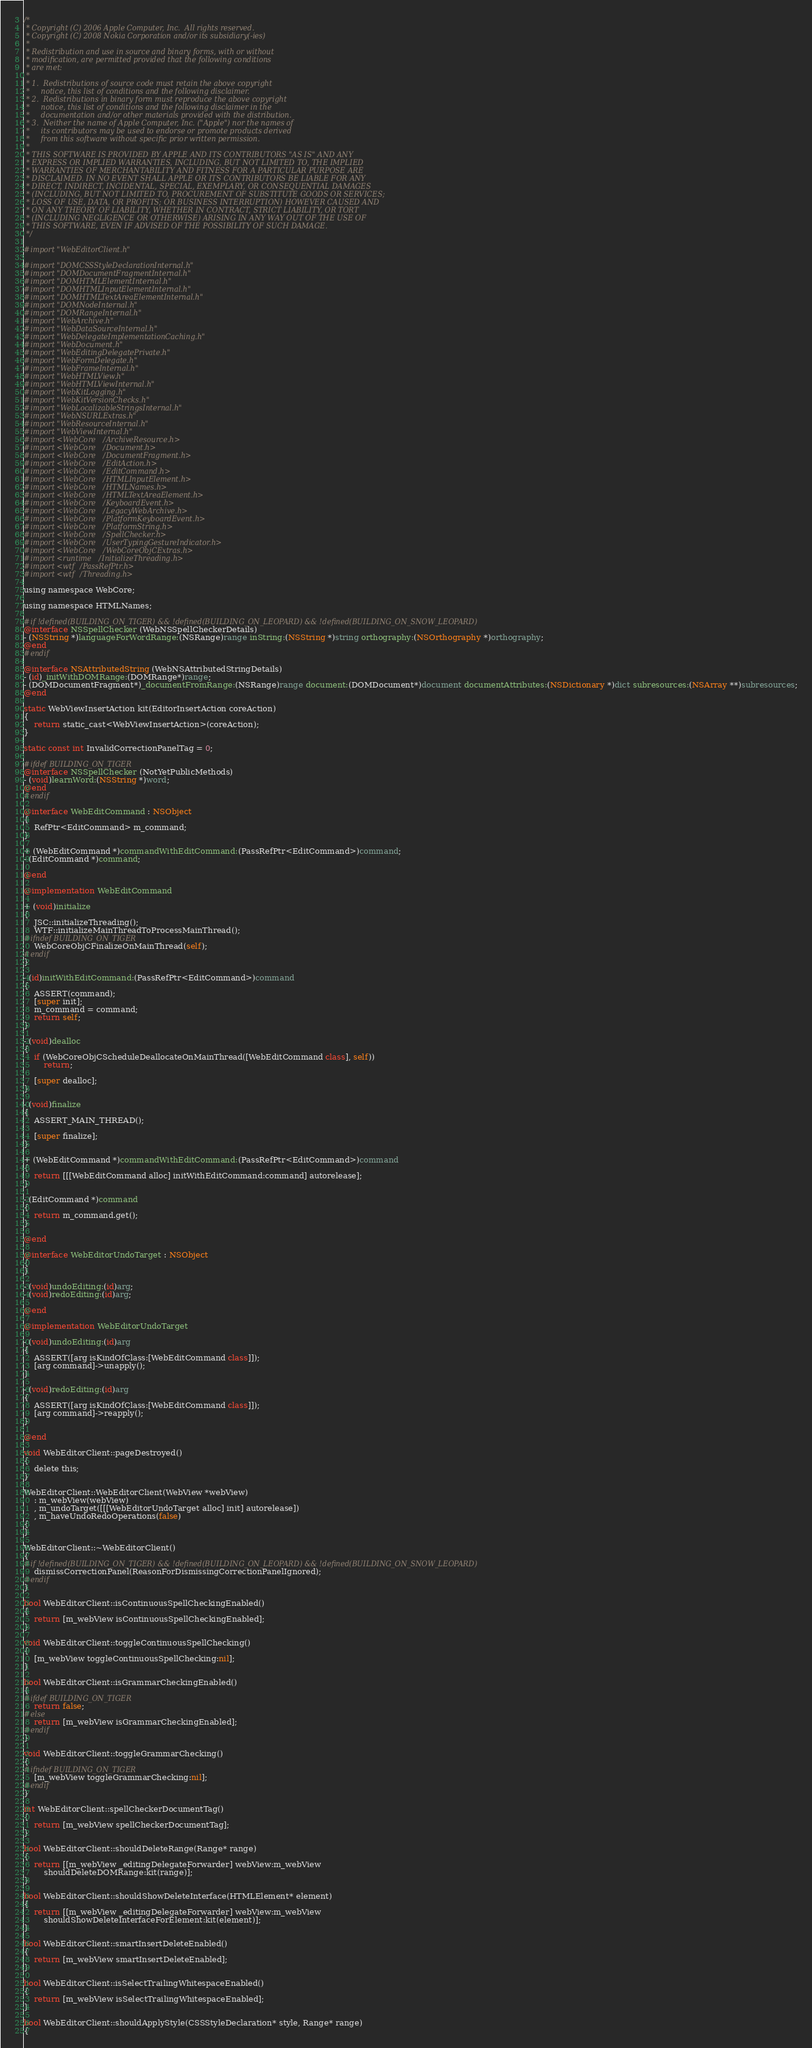Convert code to text. <code><loc_0><loc_0><loc_500><loc_500><_ObjectiveC_>/*
 * Copyright (C) 2006 Apple Computer, Inc.  All rights reserved.
 * Copyright (C) 2008 Nokia Corporation and/or its subsidiary(-ies)
 *
 * Redistribution and use in source and binary forms, with or without
 * modification, are permitted provided that the following conditions
 * are met:
 *
 * 1.  Redistributions of source code must retain the above copyright
 *     notice, this list of conditions and the following disclaimer. 
 * 2.  Redistributions in binary form must reproduce the above copyright
 *     notice, this list of conditions and the following disclaimer in the
 *     documentation and/or other materials provided with the distribution. 
 * 3.  Neither the name of Apple Computer, Inc. ("Apple") nor the names of
 *     its contributors may be used to endorse or promote products derived
 *     from this software without specific prior written permission. 
 *
 * THIS SOFTWARE IS PROVIDED BY APPLE AND ITS CONTRIBUTORS "AS IS" AND ANY
 * EXPRESS OR IMPLIED WARRANTIES, INCLUDING, BUT NOT LIMITED TO, THE IMPLIED
 * WARRANTIES OF MERCHANTABILITY AND FITNESS FOR A PARTICULAR PURPOSE ARE
 * DISCLAIMED. IN NO EVENT SHALL APPLE OR ITS CONTRIBUTORS BE LIABLE FOR ANY
 * DIRECT, INDIRECT, INCIDENTAL, SPECIAL, EXEMPLARY, OR CONSEQUENTIAL DAMAGES
 * (INCLUDING, BUT NOT LIMITED TO, PROCUREMENT OF SUBSTITUTE GOODS OR SERVICES;
 * LOSS OF USE, DATA, OR PROFITS; OR BUSINESS INTERRUPTION) HOWEVER CAUSED AND
 * ON ANY THEORY OF LIABILITY, WHETHER IN CONTRACT, STRICT LIABILITY, OR TORT
 * (INCLUDING NEGLIGENCE OR OTHERWISE) ARISING IN ANY WAY OUT OF THE USE OF
 * THIS SOFTWARE, EVEN IF ADVISED OF THE POSSIBILITY OF SUCH DAMAGE.
 */

#import "WebEditorClient.h"

#import "DOMCSSStyleDeclarationInternal.h"
#import "DOMDocumentFragmentInternal.h"
#import "DOMHTMLElementInternal.h"
#import "DOMHTMLInputElementInternal.h"
#import "DOMHTMLTextAreaElementInternal.h"
#import "DOMNodeInternal.h"
#import "DOMRangeInternal.h"
#import "WebArchive.h"
#import "WebDataSourceInternal.h"
#import "WebDelegateImplementationCaching.h"
#import "WebDocument.h"
#import "WebEditingDelegatePrivate.h"
#import "WebFormDelegate.h"
#import "WebFrameInternal.h"
#import "WebHTMLView.h"
#import "WebHTMLViewInternal.h"
#import "WebKitLogging.h"
#import "WebKitVersionChecks.h"
#import "WebLocalizableStringsInternal.h"
#import "WebNSURLExtras.h"
#import "WebResourceInternal.h"
#import "WebViewInternal.h"
#import <WebCore/ArchiveResource.h>
#import <WebCore/Document.h>
#import <WebCore/DocumentFragment.h>
#import <WebCore/EditAction.h>
#import <WebCore/EditCommand.h>
#import <WebCore/HTMLInputElement.h>
#import <WebCore/HTMLNames.h>
#import <WebCore/HTMLTextAreaElement.h>
#import <WebCore/KeyboardEvent.h>
#import <WebCore/LegacyWebArchive.h>
#import <WebCore/PlatformKeyboardEvent.h>
#import <WebCore/PlatformString.h>
#import <WebCore/SpellChecker.h>
#import <WebCore/UserTypingGestureIndicator.h>
#import <WebCore/WebCoreObjCExtras.h>
#import <runtime/InitializeThreading.h>
#import <wtf/PassRefPtr.h>
#import <wtf/Threading.h>

using namespace WebCore;

using namespace HTMLNames;

#if !defined(BUILDING_ON_TIGER) && !defined(BUILDING_ON_LEOPARD) && !defined(BUILDING_ON_SNOW_LEOPARD)
@interface NSSpellChecker (WebNSSpellCheckerDetails)
- (NSString *)languageForWordRange:(NSRange)range inString:(NSString *)string orthography:(NSOrthography *)orthography;
@end
#endif

@interface NSAttributedString (WebNSAttributedStringDetails)
- (id)_initWithDOMRange:(DOMRange*)range;
- (DOMDocumentFragment*)_documentFromRange:(NSRange)range document:(DOMDocument*)document documentAttributes:(NSDictionary *)dict subresources:(NSArray **)subresources;
@end

static WebViewInsertAction kit(EditorInsertAction coreAction)
{
    return static_cast<WebViewInsertAction>(coreAction);
}

static const int InvalidCorrectionPanelTag = 0;

#ifdef BUILDING_ON_TIGER
@interface NSSpellChecker (NotYetPublicMethods)
- (void)learnWord:(NSString *)word;
@end
#endif

@interface WebEditCommand : NSObject
{
    RefPtr<EditCommand> m_command;   
}

+ (WebEditCommand *)commandWithEditCommand:(PassRefPtr<EditCommand>)command;
- (EditCommand *)command;

@end

@implementation WebEditCommand

+ (void)initialize
{
    JSC::initializeThreading();
    WTF::initializeMainThreadToProcessMainThread();
#ifndef BUILDING_ON_TIGER
    WebCoreObjCFinalizeOnMainThread(self);
#endif
}

- (id)initWithEditCommand:(PassRefPtr<EditCommand>)command
{
    ASSERT(command);
    [super init];
    m_command = command;
    return self;
}

- (void)dealloc
{
    if (WebCoreObjCScheduleDeallocateOnMainThread([WebEditCommand class], self))
        return;

    [super dealloc];
}

- (void)finalize
{
    ASSERT_MAIN_THREAD();

    [super finalize];
}

+ (WebEditCommand *)commandWithEditCommand:(PassRefPtr<EditCommand>)command
{
    return [[[WebEditCommand alloc] initWithEditCommand:command] autorelease];
}

- (EditCommand *)command
{
    return m_command.get();
}

@end

@interface WebEditorUndoTarget : NSObject
{
}

- (void)undoEditing:(id)arg;
- (void)redoEditing:(id)arg;

@end

@implementation WebEditorUndoTarget

- (void)undoEditing:(id)arg
{
    ASSERT([arg isKindOfClass:[WebEditCommand class]]);
    [arg command]->unapply();
}

- (void)redoEditing:(id)arg
{
    ASSERT([arg isKindOfClass:[WebEditCommand class]]);
    [arg command]->reapply();
}

@end

void WebEditorClient::pageDestroyed()
{
    delete this;
}

WebEditorClient::WebEditorClient(WebView *webView)
    : m_webView(webView)
    , m_undoTarget([[[WebEditorUndoTarget alloc] init] autorelease])
    , m_haveUndoRedoOperations(false)
{
}

WebEditorClient::~WebEditorClient()
{
#if !defined(BUILDING_ON_TIGER) && !defined(BUILDING_ON_LEOPARD) && !defined(BUILDING_ON_SNOW_LEOPARD)
    dismissCorrectionPanel(ReasonForDismissingCorrectionPanelIgnored);
#endif
}

bool WebEditorClient::isContinuousSpellCheckingEnabled()
{
    return [m_webView isContinuousSpellCheckingEnabled];
}

void WebEditorClient::toggleContinuousSpellChecking()
{
    [m_webView toggleContinuousSpellChecking:nil];
}

bool WebEditorClient::isGrammarCheckingEnabled()
{
#ifdef BUILDING_ON_TIGER
    return false;
#else
    return [m_webView isGrammarCheckingEnabled];
#endif
}

void WebEditorClient::toggleGrammarChecking()
{
#ifndef BUILDING_ON_TIGER
    [m_webView toggleGrammarChecking:nil];
#endif
}

int WebEditorClient::spellCheckerDocumentTag()
{
    return [m_webView spellCheckerDocumentTag];
}

bool WebEditorClient::shouldDeleteRange(Range* range)
{
    return [[m_webView _editingDelegateForwarder] webView:m_webView
        shouldDeleteDOMRange:kit(range)];
}

bool WebEditorClient::shouldShowDeleteInterface(HTMLElement* element)
{
    return [[m_webView _editingDelegateForwarder] webView:m_webView
        shouldShowDeleteInterfaceForElement:kit(element)];
}

bool WebEditorClient::smartInsertDeleteEnabled()
{
    return [m_webView smartInsertDeleteEnabled];
}

bool WebEditorClient::isSelectTrailingWhitespaceEnabled()
{
    return [m_webView isSelectTrailingWhitespaceEnabled];
}

bool WebEditorClient::shouldApplyStyle(CSSStyleDeclaration* style, Range* range)
{</code> 